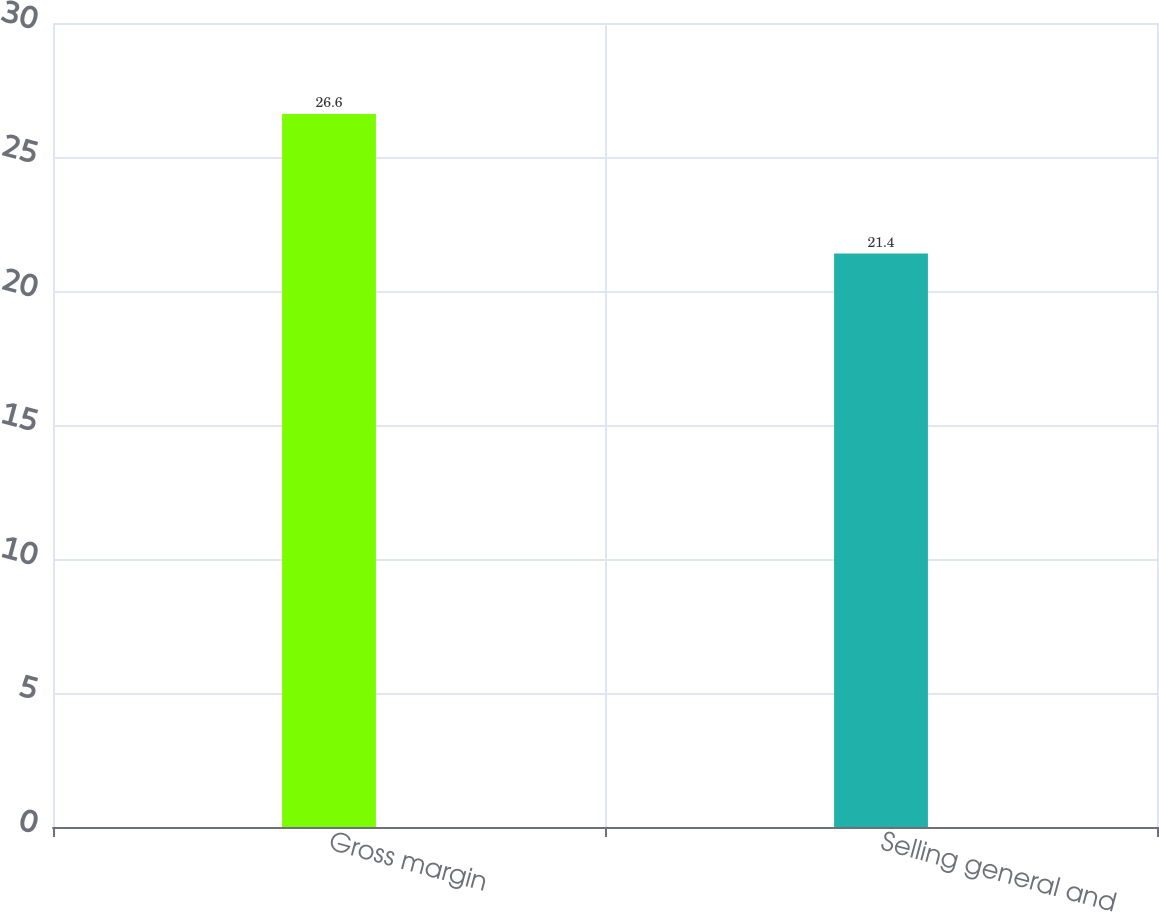Convert chart. <chart><loc_0><loc_0><loc_500><loc_500><bar_chart><fcel>Gross margin<fcel>Selling general and<nl><fcel>26.6<fcel>21.4<nl></chart> 